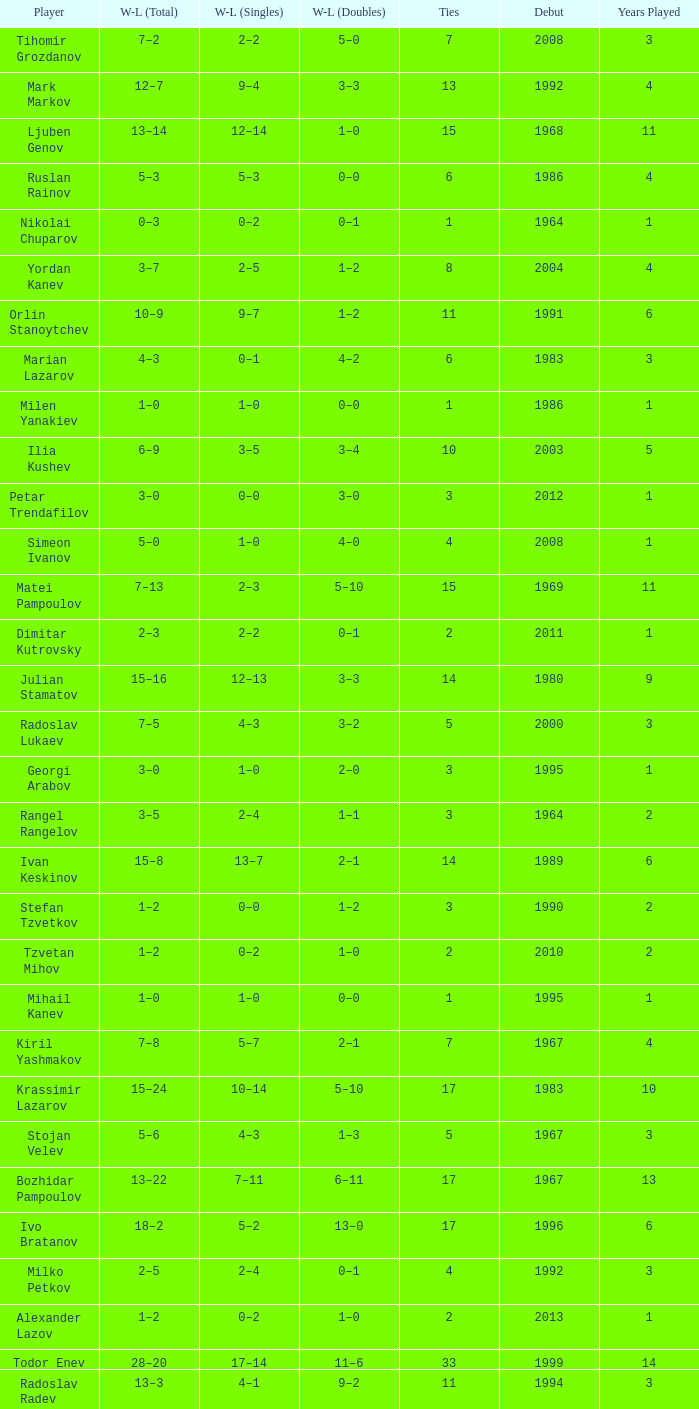Tell me the WL doubles with a debut of 1999 11–6. 